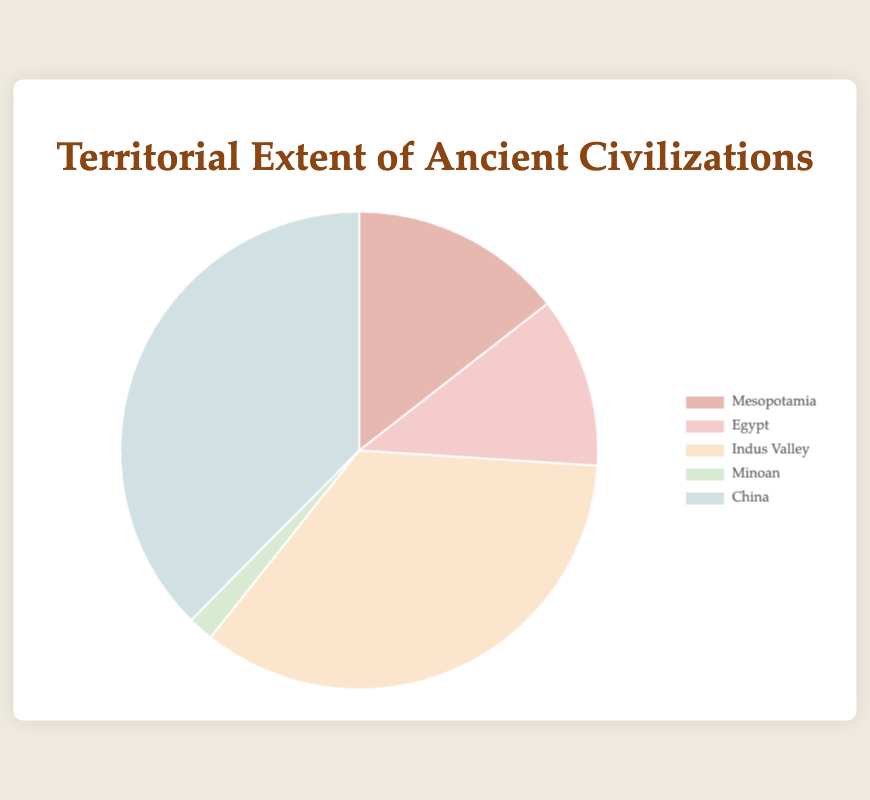Which civilization had the largest territorial extent? To determine the civilization with the largest territorial extent, observe the slice of the pie chart that represents the greatest portion. This is indicated by the size of the segment labeled "China," with 1,300,000 km².
Answer: China How much larger is the territorial extent of China compared to Mesopotamia? The territorial extent of China is 1,300,000 km², while that of Mesopotamia is 500,000 km². To find the difference, subtract Mesopotamia’s extent from China’s extent: 1,300,000 km² - 500,000 km² = 800,000 km².
Answer: 800,000 km² What percentage of the total territorial extent does the Indus Valley civilization occupy? First, calculate the total territorial extent by summing all extents: 500,000 + 400,000 + 1,200,000 + 60,000 + 1,300,000 = 3,460,000 km². The Indus Valley's extent is 1,200,000 km². The percentage is calculated as (1,200,000 / 3,460,000) * 100 ≈ 34.68%.
Answer: 34.68% Which two civilizations have the smallest combined territorial extent? Identify the civilizations with the smallest segments in the pie chart, which are the Minoan (60,000 km²) and Egypt (400,000 km²). Add their extents: 60,000 km² + 400,000 km² = 460,000 km².
Answer: Minoan and Egypt What is the average territorial extent of the civilizations? Sum the territorial extents of all civilizations: 500,000 + 400,000 + 1,200,000 + 60,000 + 1,300,000 = 3,460,000 km². Then divide by the number of civilizations (5): 3,460,000 km² / 5 = 692,000 km².
Answer: 692,000 km² By what factor is the territorial extent of China larger than that of the Minoan civilization? The territorial extent of China is 1,300,000 km², and that of the Minoan civilization is 60,000 km². To find the factor by which China's extent is larger: 1,300,000 km² / 60,000 km² ≈ 21.67.
Answer: 21.67 Which civilization is represented by the segment colored in green? Identify the color associated with each segment. The green segment represents the Minoan civilization.
Answer: Minoan How does the combined territorial extent of Mesopotamia and Egypt compare to that of the Indus Valley? Sum the extents of Mesopotamia (500,000 km²) and Egypt (400,000 km²): 500,000 + 400,000 = 900,000 km². Compare this to the Indus Valley's extent of 1,200,000 km². The Indus Valley has a larger extent by 1,200,000 km² - 900,000 km² = 300,000 km².
Answer: Indus Valley is larger by 300,000 km² What fraction of the total territorial extent is occupied by Minoan civilization? First, determine the total extent: 3,460,000 km². The Minoan civilization has an extent of 60,000 km². The fraction is 60,000 / 3,460,000 ≈ 0.0173.
Answer: 0.0173 